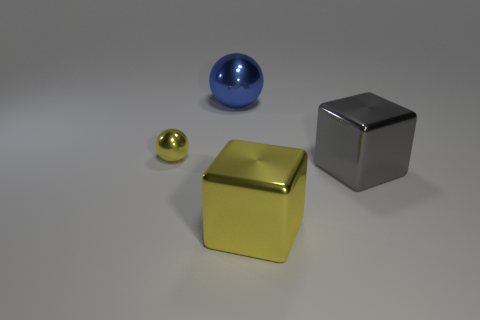Add 3 yellow objects. How many objects exist? 7 Subtract all yellow cubes. How many cubes are left? 1 Subtract 1 balls. How many balls are left? 1 Subtract all brown balls. How many red blocks are left? 0 Subtract all blue objects. Subtract all big metal balls. How many objects are left? 2 Add 4 small yellow objects. How many small yellow objects are left? 5 Add 2 small yellow spheres. How many small yellow spheres exist? 3 Subtract 1 gray cubes. How many objects are left? 3 Subtract all blue balls. Subtract all green blocks. How many balls are left? 1 